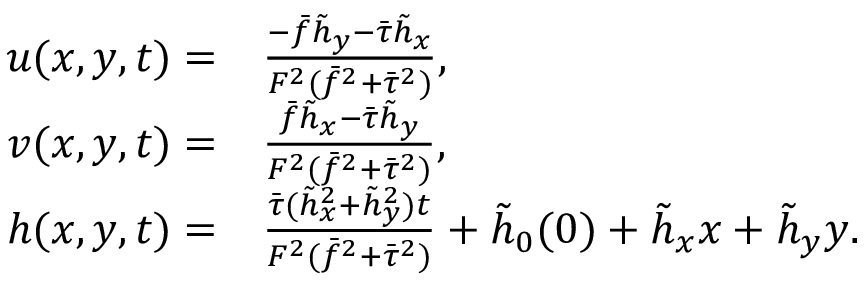Convert formula to latex. <formula><loc_0><loc_0><loc_500><loc_500>\begin{array} { r l } { u ( x , y , t ) = } & { \frac { - \bar { f } \tilde { h } _ { y } - \bar { \tau } \tilde { h } _ { x } } { F ^ { 2 } ( \bar { f } ^ { 2 } + \bar { \tau } ^ { 2 } ) } , } \\ { v ( x , y , t ) = } & { \frac { \bar { f } \tilde { h } _ { x } - \bar { \tau } \tilde { h } _ { y } } { F ^ { 2 } ( \bar { f } ^ { 2 } + \bar { \tau } ^ { 2 } ) } , } \\ { h ( x , y , t ) = } & { \frac { \bar { \tau } ( \tilde { h } _ { x } ^ { 2 } + \tilde { h } _ { y } ^ { 2 } ) t } { F ^ { 2 } ( \bar { f } ^ { 2 } + \bar { \tau } ^ { 2 } ) } + \tilde { h } _ { 0 } ( 0 ) + \tilde { h } _ { x } x + \tilde { h } _ { y } y . } \end{array}</formula> 